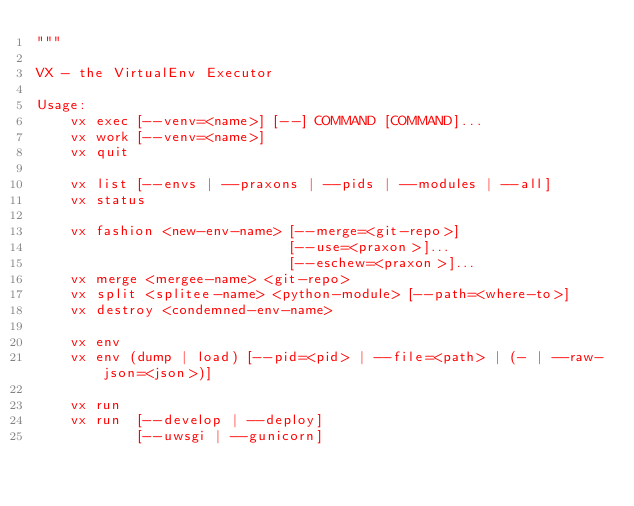Convert code to text. <code><loc_0><loc_0><loc_500><loc_500><_Python_>"""

VX - the VirtualEnv Executor

Usage:
    vx exec [--venv=<name>] [--] COMMAND [COMMAND]...
    vx work [--venv=<name>]
    vx quit
    
    vx list [--envs | --praxons | --pids | --modules | --all]
    vx status
    
    vx fashion <new-env-name> [--merge=<git-repo>]
                              [--use=<praxon>]...
                              [--eschew=<praxon>]...
    vx merge <mergee-name> <git-repo>
    vx split <splitee-name> <python-module> [--path=<where-to>]
    vx destroy <condemned-env-name>
    
    vx env
    vx env (dump | load) [--pid=<pid> | --file=<path> | (- | --raw-json=<json>)]
    
    vx run
    vx run  [--develop | --deploy]
            [--uwsgi | --gunicorn]</code> 